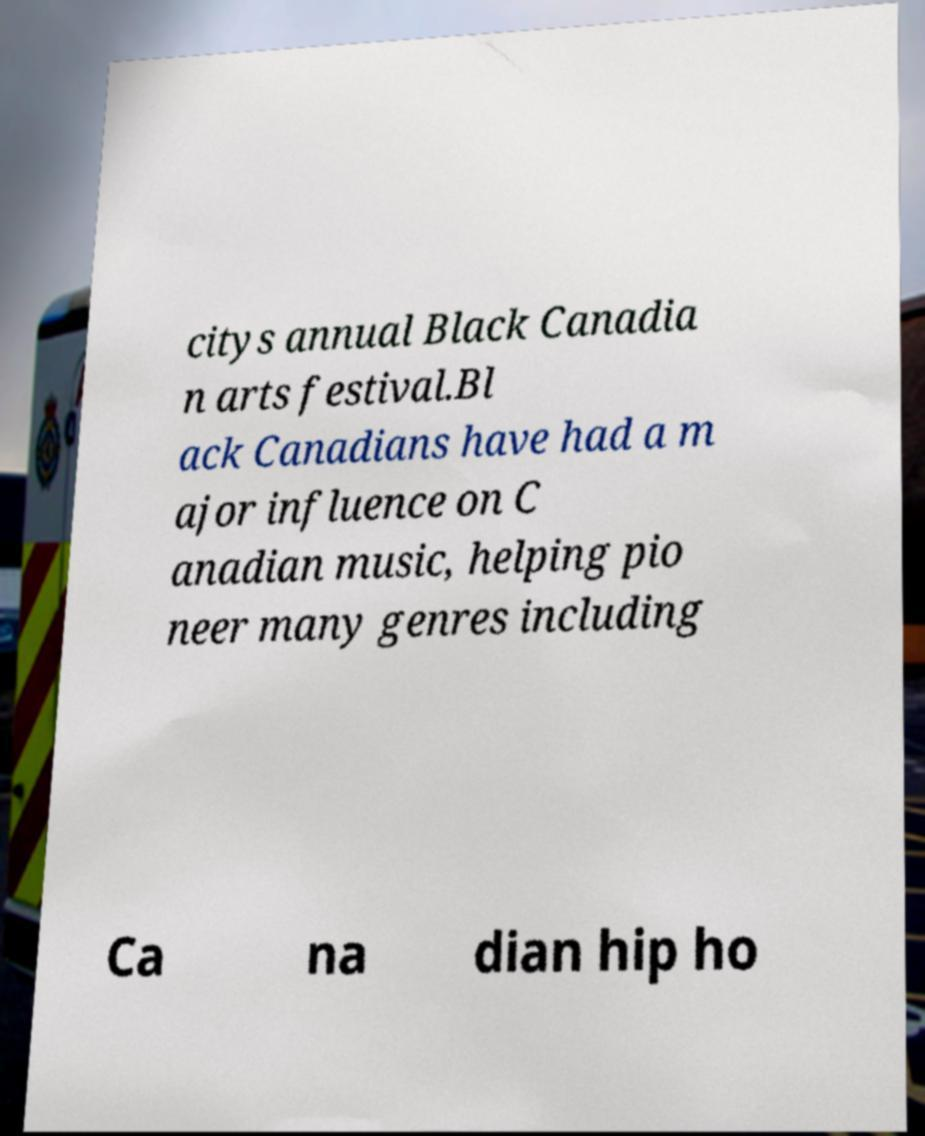There's text embedded in this image that I need extracted. Can you transcribe it verbatim? citys annual Black Canadia n arts festival.Bl ack Canadians have had a m ajor influence on C anadian music, helping pio neer many genres including Ca na dian hip ho 